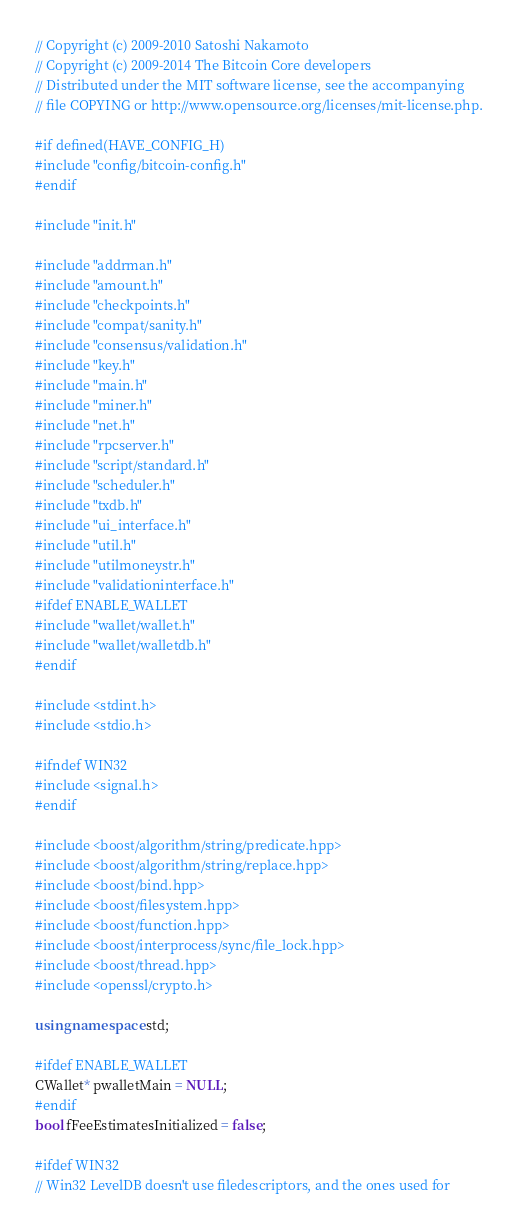<code> <loc_0><loc_0><loc_500><loc_500><_C++_>// Copyright (c) 2009-2010 Satoshi Nakamoto
// Copyright (c) 2009-2014 The Bitcoin Core developers
// Distributed under the MIT software license, see the accompanying
// file COPYING or http://www.opensource.org/licenses/mit-license.php.

#if defined(HAVE_CONFIG_H)
#include "config/bitcoin-config.h"
#endif

#include "init.h"

#include "addrman.h"
#include "amount.h"
#include "checkpoints.h"
#include "compat/sanity.h"
#include "consensus/validation.h"
#include "key.h"
#include "main.h"
#include "miner.h"
#include "net.h"
#include "rpcserver.h"
#include "script/standard.h"
#include "scheduler.h"
#include "txdb.h"
#include "ui_interface.h"
#include "util.h"
#include "utilmoneystr.h"
#include "validationinterface.h"
#ifdef ENABLE_WALLET
#include "wallet/wallet.h"
#include "wallet/walletdb.h"
#endif

#include <stdint.h>
#include <stdio.h>

#ifndef WIN32
#include <signal.h>
#endif

#include <boost/algorithm/string/predicate.hpp>
#include <boost/algorithm/string/replace.hpp>
#include <boost/bind.hpp>
#include <boost/filesystem.hpp>
#include <boost/function.hpp>
#include <boost/interprocess/sync/file_lock.hpp>
#include <boost/thread.hpp>
#include <openssl/crypto.h>

using namespace std;

#ifdef ENABLE_WALLET
CWallet* pwalletMain = NULL;
#endif
bool fFeeEstimatesInitialized = false;

#ifdef WIN32
// Win32 LevelDB doesn't use filedescriptors, and the ones used for</code> 